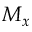Convert formula to latex. <formula><loc_0><loc_0><loc_500><loc_500>M _ { x }</formula> 